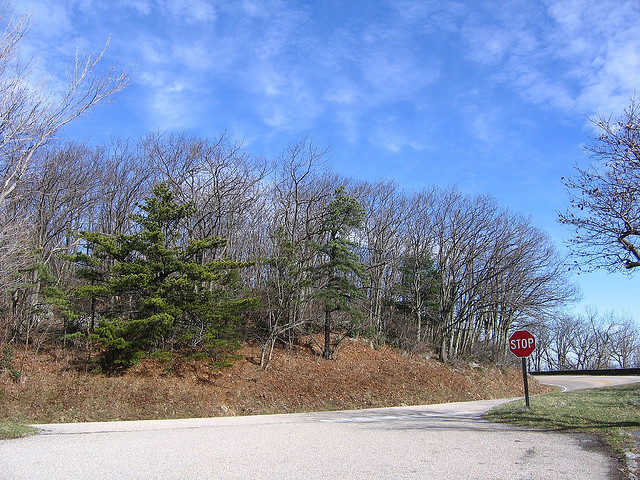Please extract the text content from this image. STOP 